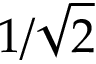Convert formula to latex. <formula><loc_0><loc_0><loc_500><loc_500>1 / { \sqrt { 2 } }</formula> 